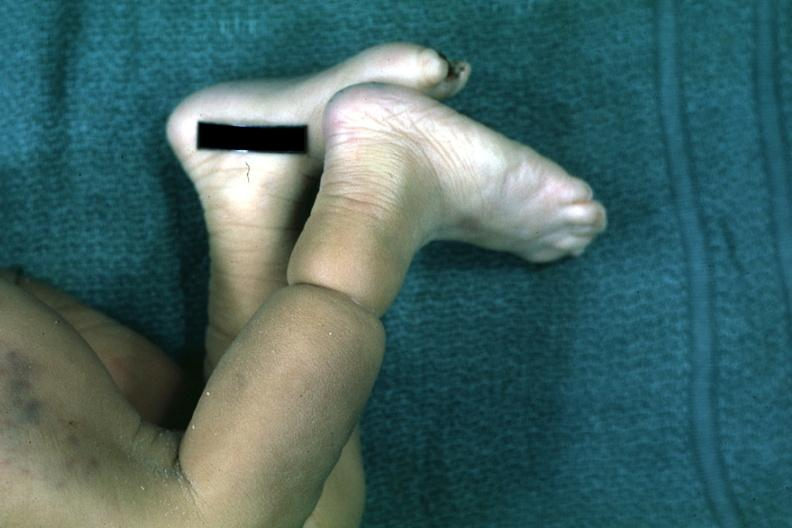s that looks like an amniotic band lesion?
Answer the question using a single word or phrase. Yes 